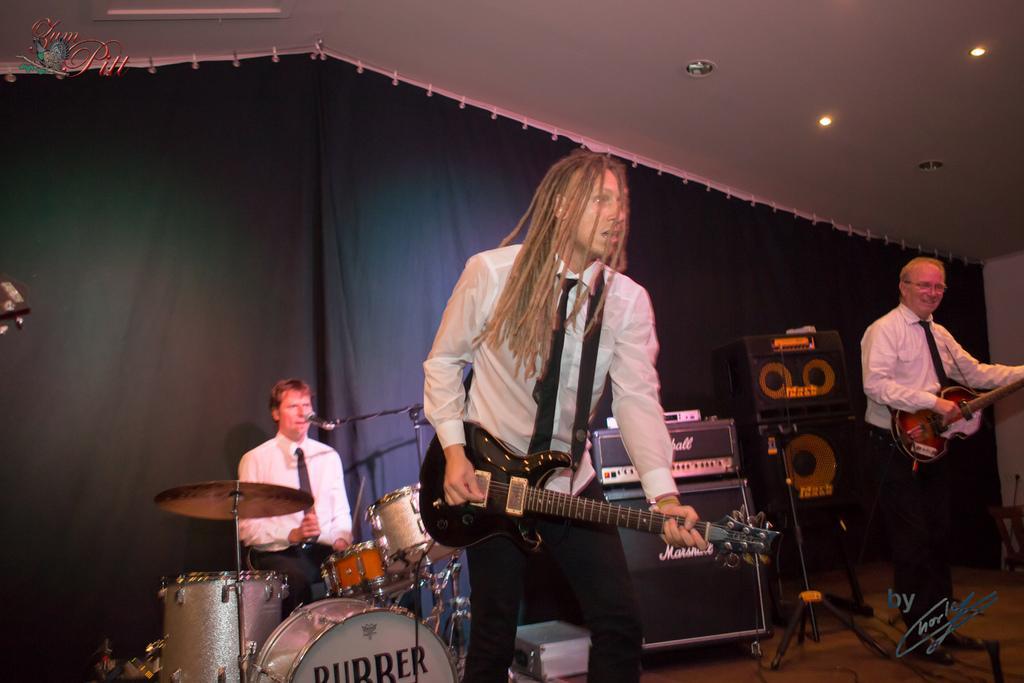Please provide a concise description of this image. At the top we can see ceiling and lights. There is a cloth on the background. We can see one man sitting and playing drums in front of a mike. Here we can see two men standing and playing guitar. These are speakers. This is an electronic device. This is a platform. 